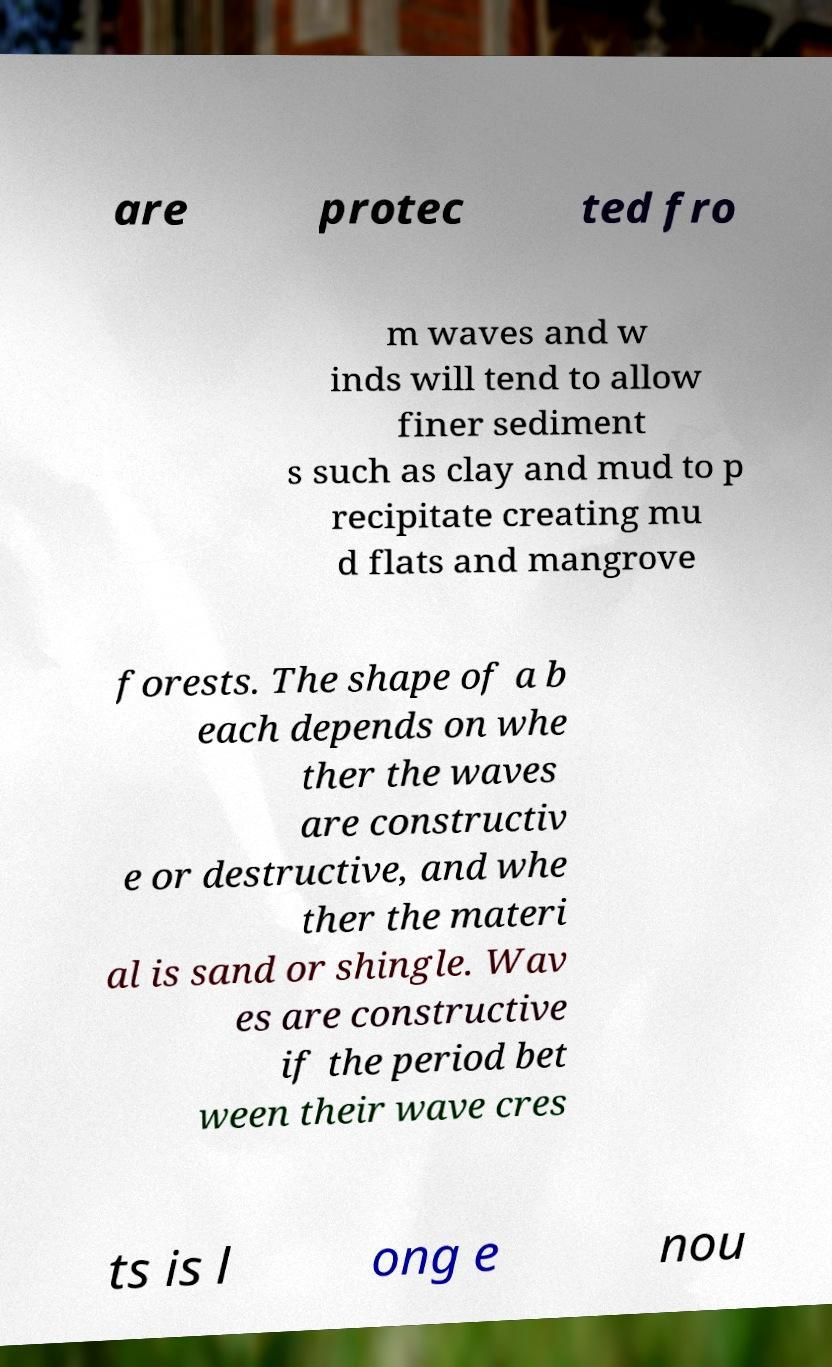Could you extract and type out the text from this image? are protec ted fro m waves and w inds will tend to allow finer sediment s such as clay and mud to p recipitate creating mu d flats and mangrove forests. The shape of a b each depends on whe ther the waves are constructiv e or destructive, and whe ther the materi al is sand or shingle. Wav es are constructive if the period bet ween their wave cres ts is l ong e nou 